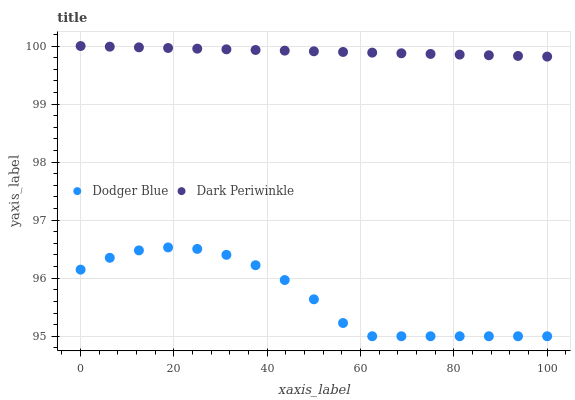Does Dodger Blue have the minimum area under the curve?
Answer yes or no. Yes. Does Dark Periwinkle have the maximum area under the curve?
Answer yes or no. Yes. Does Dark Periwinkle have the minimum area under the curve?
Answer yes or no. No. Is Dark Periwinkle the smoothest?
Answer yes or no. Yes. Is Dodger Blue the roughest?
Answer yes or no. Yes. Is Dark Periwinkle the roughest?
Answer yes or no. No. Does Dodger Blue have the lowest value?
Answer yes or no. Yes. Does Dark Periwinkle have the lowest value?
Answer yes or no. No. Does Dark Periwinkle have the highest value?
Answer yes or no. Yes. Is Dodger Blue less than Dark Periwinkle?
Answer yes or no. Yes. Is Dark Periwinkle greater than Dodger Blue?
Answer yes or no. Yes. Does Dodger Blue intersect Dark Periwinkle?
Answer yes or no. No. 